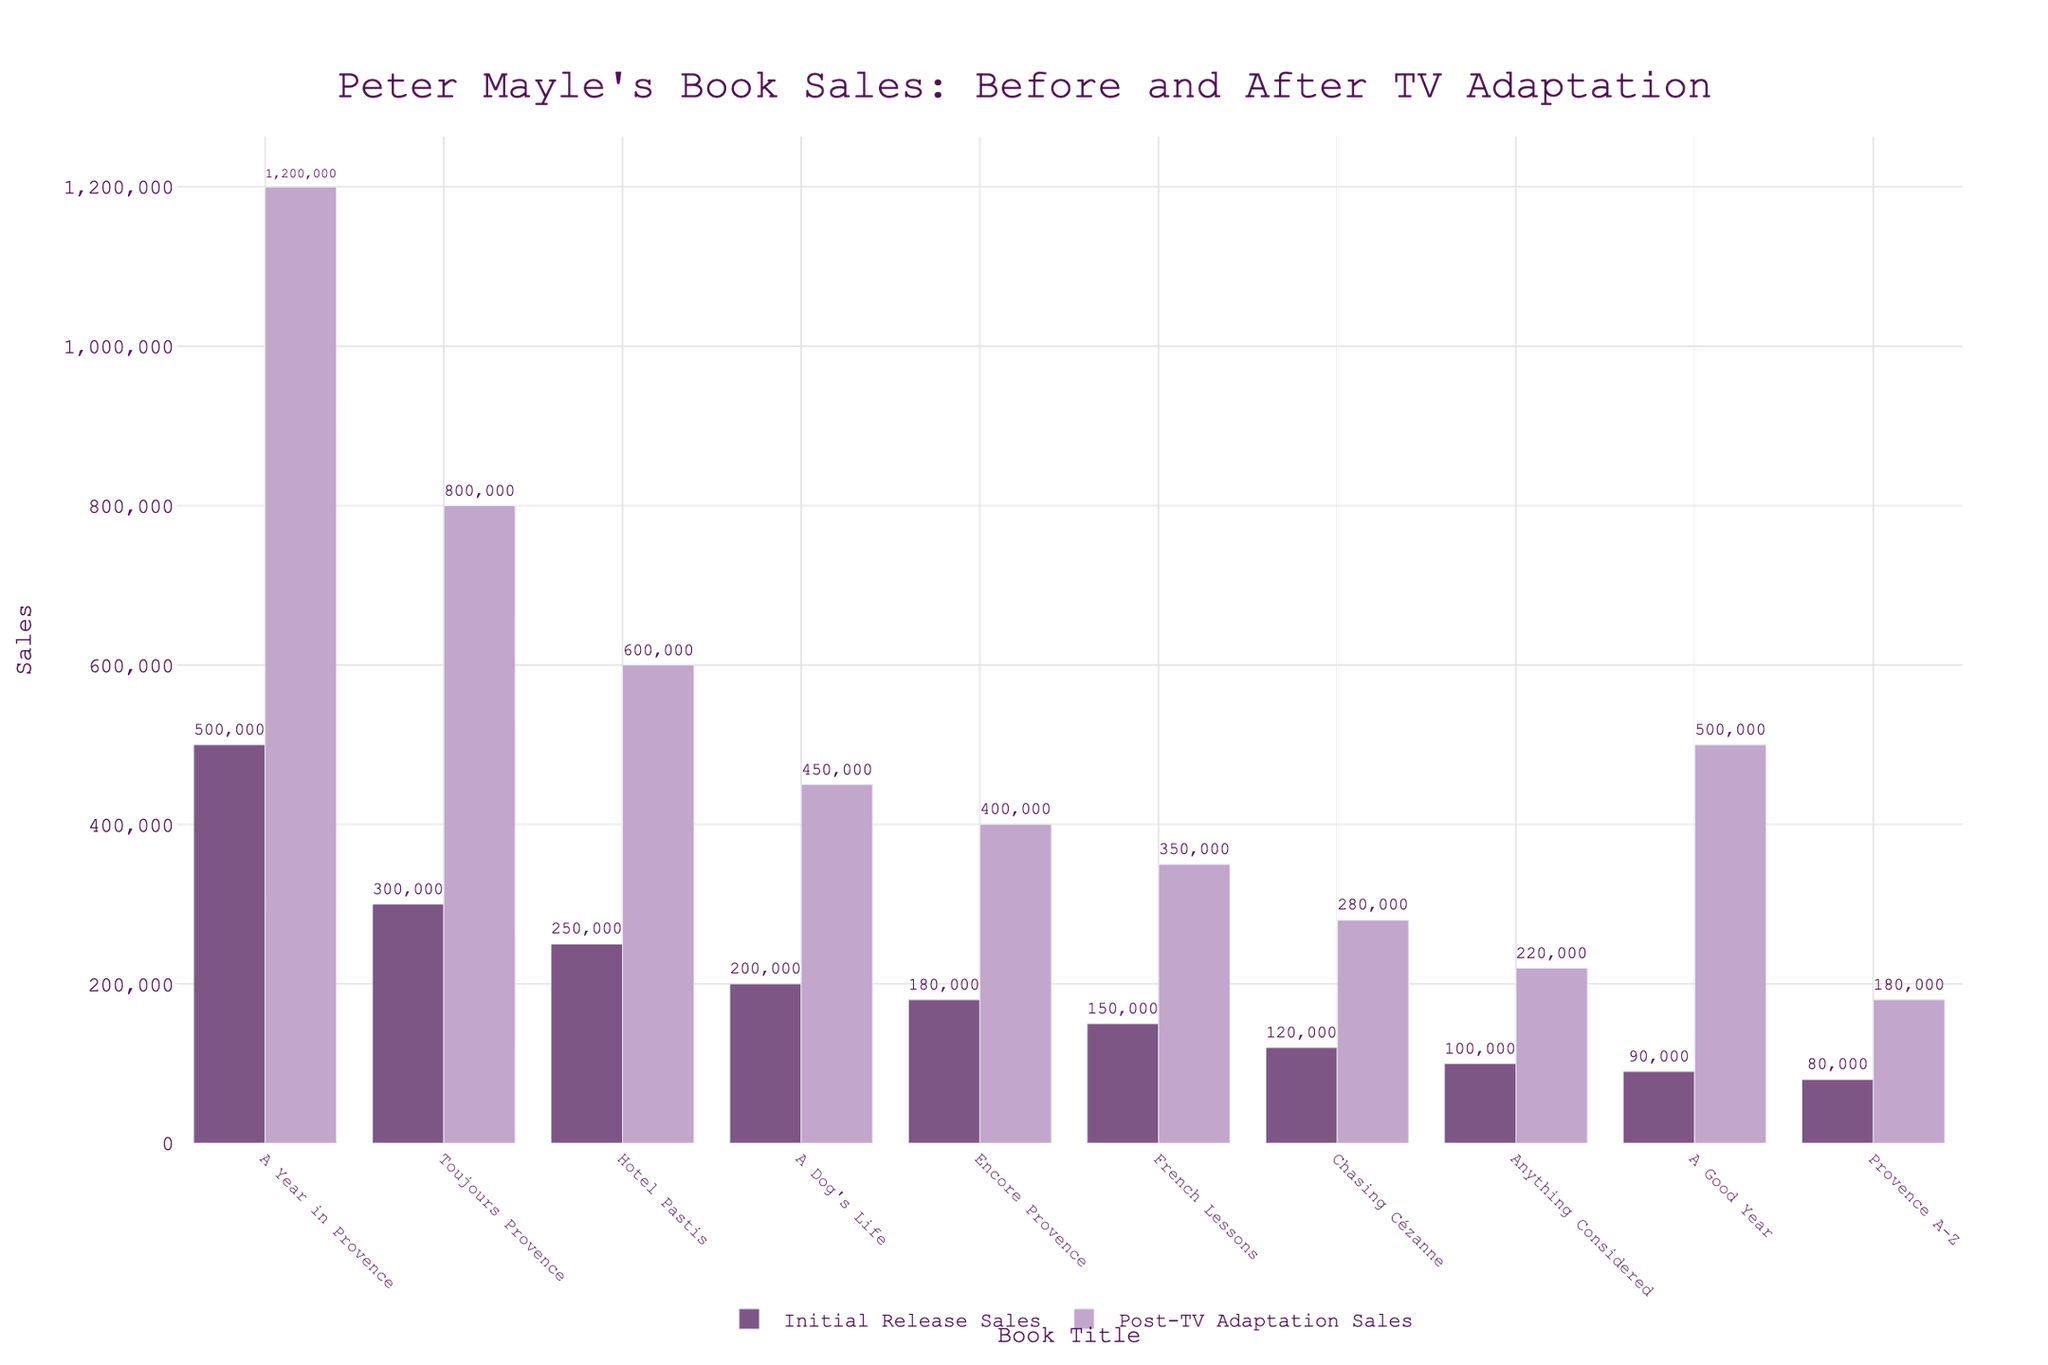Which book had the highest sales after the TV adaptation? Look at the heights of the bars representing Post-TV Adaptation Sales and identify which bar is the tallest. "A Year in Provence" has the highest sales.
Answer: A Year in Provence What is the total difference in sales for "Hotel Pastis" before and after the TV adaptation? First, find the sales numbers for "Hotel Pastis" before (250,000) and after (600,000) the TV adaptation. Then, subtract the initial sales from the post-TV adaptation sales: 600,000 - 250,000.
Answer: 350,000 Compare the initial release sales of "A Good Year" and "Provence A-Z". Which book had higher initial sales and by how much? Look at the heights of the bars representing Initial Release Sales for both titles. "A Good Year" had 90,000 initial sales, and "Provence A-Z" had 80,000 initial sales. Subtract the latter from the former: 90,000 - 80,000.
Answer: A Good Year, 10,000 Which book saw an increase of exactly 200,000 in sales after the TV adaptation? Find the books where the difference between Initial Release Sales and Post-TV Adaptation Sales is exactly 200,000. "Chasing Cézanne" fits this criterion with initial sales of 120,000 and post-TV sales of 280,000.
Answer: Chasing Cézanne What is the average initial release sales of "Encore Provence", "French Lessons", and "Chasing Cézanne"? Add the initial release sales of the three books: 180,000 + 150,000 + 120,000 = 450,000. Then divide by the number of books: 450,000 / 3.
Answer: 150,000 Which book had the least sales increase after the TV adaptation? Calculate the difference between Post-TV Adaptation Sales and Initial Release Sales for each book. "Provence A-Z" had the smallest increase with 180,000 - 80,000.
Answer: Provence A-Z How much more did "Toujours Provence" sell after the TV adaptation compared to "A Dog's Life"? Look at Post-TV Adaptation Sales for "Toujours Provence" (800,000) and "A Dog's Life" (450,000). Subtract the sales of "A Dog's Life" from the sales of "Toujours Provence": 800,000 - 450,000.
Answer: 350,000 What is the range of initial release sales values across the books listed? Find the highest and lowest initial release sales values, which are "A Year in Provence" (500,000) and "Provence A-Z" (80,000), respectively. Subtract the smallest value from the largest: 500,000 - 80,000.
Answer: 420,000 What percentage increase did "A Good Year" experience in sales after the TV adaptation? Initial sales for "A Good Year" were 90,000, and post-TV adaptation sales were 500,000. Calculate the increase: 500,000 - 90,000 = 410,000. Then, divide the increase by the initial sales and multiply by 100 to find the percentage: (410,000 / 90,000) * 100.
Answer: 455.56% 